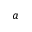Convert formula to latex. <formula><loc_0><loc_0><loc_500><loc_500>a</formula> 